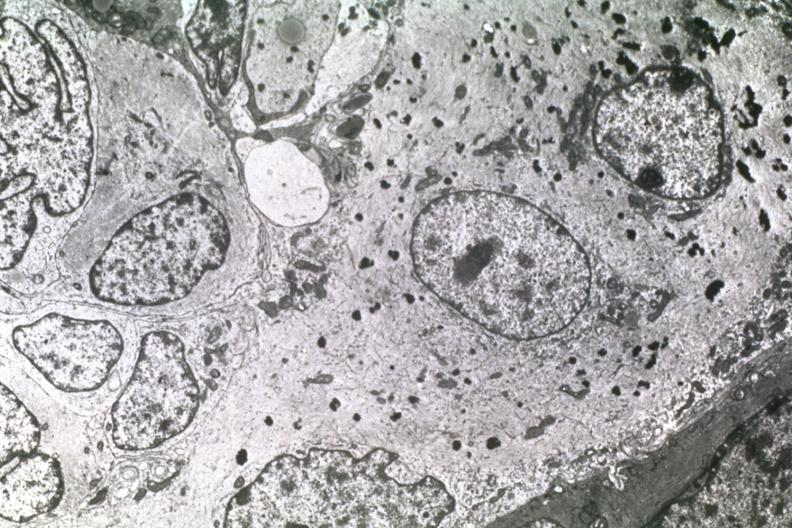what is present?
Answer the question using a single word or phrase. Brain 